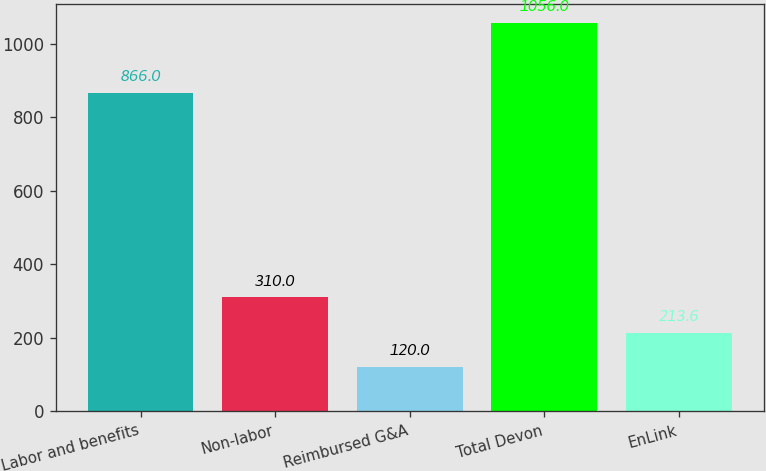<chart> <loc_0><loc_0><loc_500><loc_500><bar_chart><fcel>Labor and benefits<fcel>Non-labor<fcel>Reimbursed G&A<fcel>Total Devon<fcel>EnLink<nl><fcel>866<fcel>310<fcel>120<fcel>1056<fcel>213.6<nl></chart> 